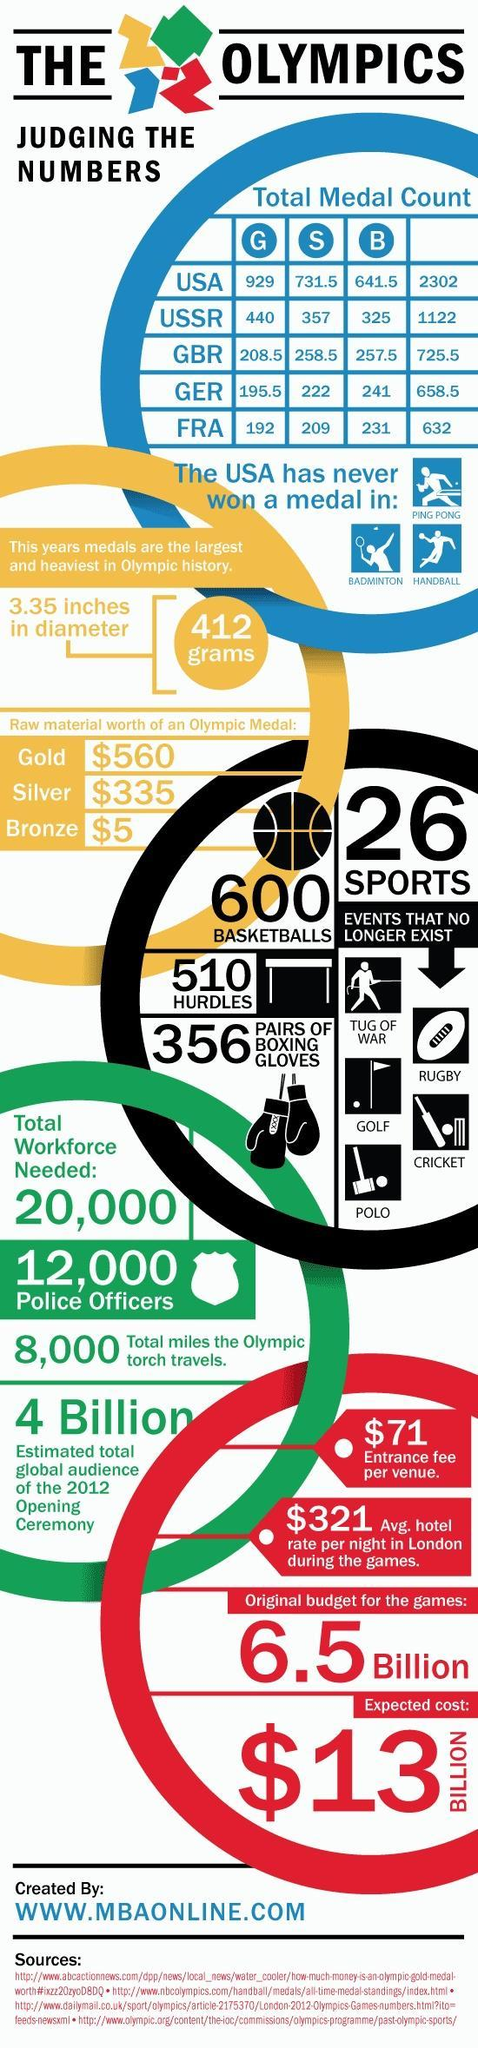What is the raw material worth of a bronze olympic medal?
Answer the question with a short phrase. $5 What is the total miles in the olympic torch travels? 8,000 What is the number of sport games included in olympics? 26 What is the entrance fee per venue for 2012 opening ceremony of the olympics? $71 What is the raw material worth of a gold olympic medal? $560 Which country has never won a medal in badminton game in Olympics? USA 